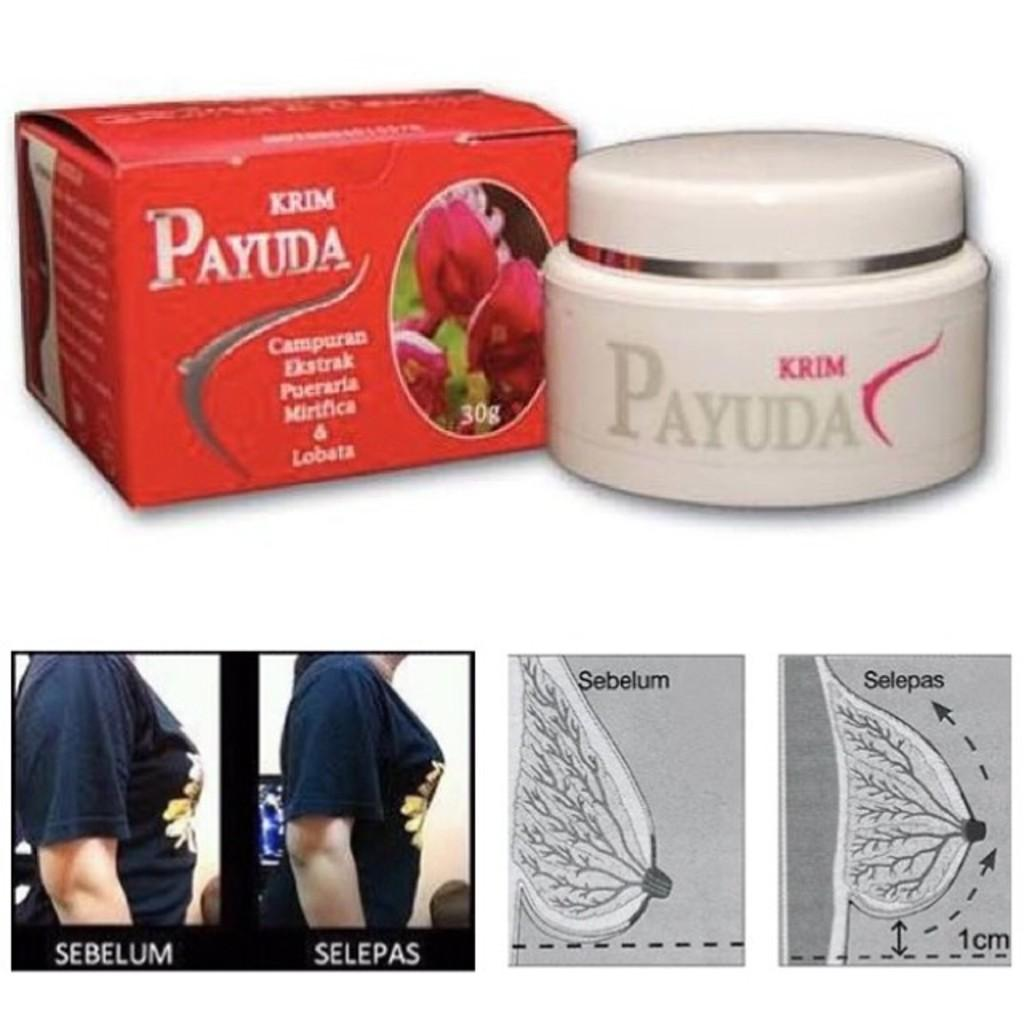<image>
Present a compact description of the photo's key features. Cream called Payuda that is supposed to help keep breasts firm. 